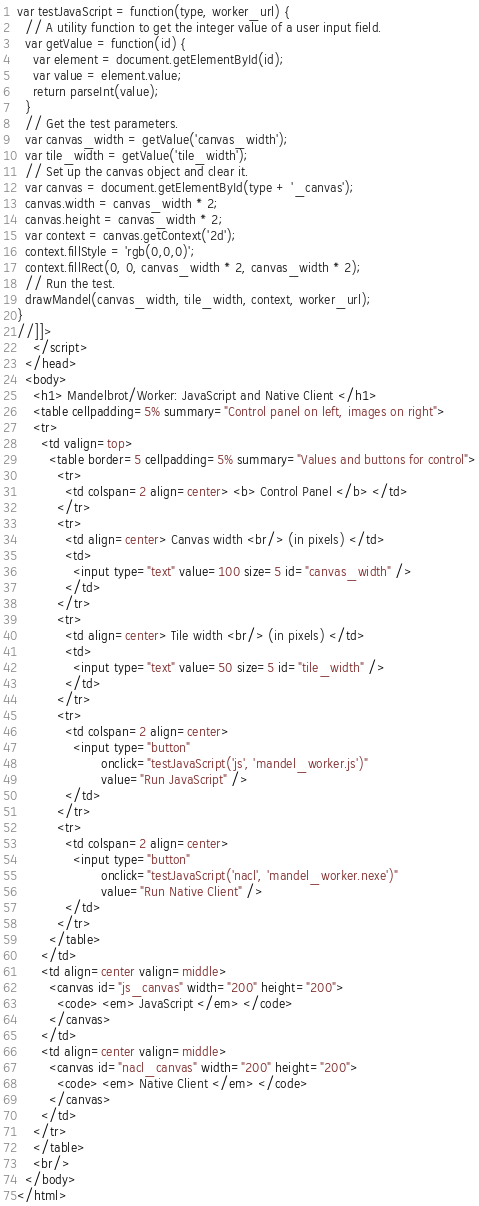Convert code to text. <code><loc_0><loc_0><loc_500><loc_500><_HTML_>var testJavaScript = function(type, worker_url) {
  // A utility function to get the integer value of a user input field.
  var getValue = function(id) {
    var element = document.getElementById(id);
    var value = element.value;
    return parseInt(value);
  }
  // Get the test parameters.
  var canvas_width = getValue('canvas_width');
  var tile_width = getValue('tile_width');
  // Set up the canvas object and clear it.
  var canvas = document.getElementById(type + '_canvas');
  canvas.width = canvas_width * 2;
  canvas.height = canvas_width * 2;
  var context = canvas.getContext('2d');
  context.fillStyle = 'rgb(0,0,0)';
  context.fillRect(0, 0, canvas_width * 2, canvas_width * 2);
  // Run the test.
  drawMandel(canvas_width, tile_width, context, worker_url);
}
//]]>
    </script>
  </head>
  <body>
    <h1> Mandelbrot/Worker: JavaScript and Native Client </h1>
    <table cellpadding=5% summary="Control panel on left, images on right">
    <tr>
      <td valign=top>
        <table border=5 cellpadding=5% summary="Values and buttons for control">
          <tr>
            <td colspan=2 align=center> <b> Control Panel </b> </td>
          </tr>
          <tr>
            <td align=center> Canvas width <br/> (in pixels) </td>
            <td>
              <input type="text" value=100 size=5 id="canvas_width" />
            </td>
          </tr>
          <tr>
            <td align=center> Tile width <br/> (in pixels) </td>
            <td>
              <input type="text" value=50 size=5 id="tile_width" />
            </td>
          </tr>
          <tr>
            <td colspan=2 align=center>
              <input type="button"
                     onclick="testJavaScript('js', 'mandel_worker.js')"
                     value="Run JavaScript" />
            </td>
          </tr>
          <tr>
            <td colspan=2 align=center>
              <input type="button"
                     onclick="testJavaScript('nacl', 'mandel_worker.nexe')"
                     value="Run Native Client" />
            </td>
          </tr>
        </table>
      </td>
      <td align=center valign=middle>
        <canvas id="js_canvas" width="200" height="200">
          <code> <em> JavaScript </em> </code>
        </canvas>
      </td>
      <td align=center valign=middle>
        <canvas id="nacl_canvas" width="200" height="200">
          <code> <em> Native Client </em> </code>
        </canvas>
      </td>
    </tr>
    </table>
    <br/>
  </body>
</html>
</code> 